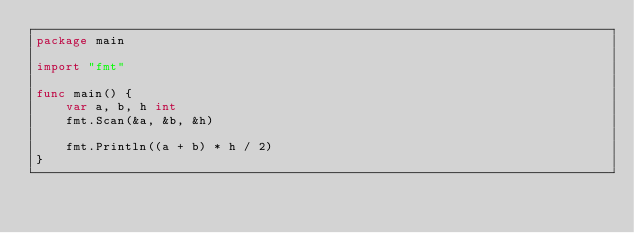<code> <loc_0><loc_0><loc_500><loc_500><_Go_>package main

import "fmt"

func main() {
	var a, b, h int
	fmt.Scan(&a, &b, &h)

	fmt.Println((a + b) * h / 2)
}
</code> 